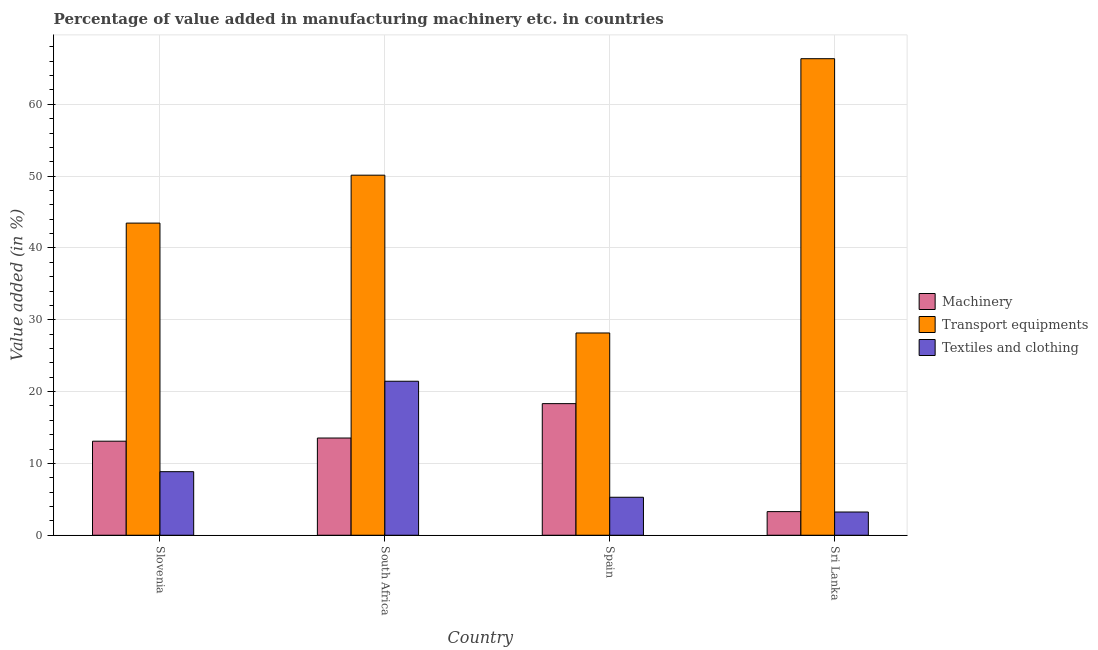How many different coloured bars are there?
Make the answer very short. 3. How many groups of bars are there?
Keep it short and to the point. 4. How many bars are there on the 3rd tick from the right?
Offer a very short reply. 3. In how many cases, is the number of bars for a given country not equal to the number of legend labels?
Keep it short and to the point. 0. What is the value added in manufacturing transport equipments in Spain?
Offer a very short reply. 28.16. Across all countries, what is the maximum value added in manufacturing textile and clothing?
Make the answer very short. 21.44. Across all countries, what is the minimum value added in manufacturing textile and clothing?
Provide a succinct answer. 3.23. In which country was the value added in manufacturing machinery maximum?
Keep it short and to the point. Spain. In which country was the value added in manufacturing machinery minimum?
Provide a short and direct response. Sri Lanka. What is the total value added in manufacturing textile and clothing in the graph?
Provide a succinct answer. 38.81. What is the difference between the value added in manufacturing transport equipments in Spain and that in Sri Lanka?
Provide a short and direct response. -38.19. What is the difference between the value added in manufacturing textile and clothing in Slovenia and the value added in manufacturing transport equipments in Sri Lanka?
Ensure brevity in your answer.  -57.5. What is the average value added in manufacturing textile and clothing per country?
Your answer should be very brief. 9.7. What is the difference between the value added in manufacturing machinery and value added in manufacturing textile and clothing in Spain?
Offer a terse response. 13.03. What is the ratio of the value added in manufacturing transport equipments in Spain to that in Sri Lanka?
Offer a very short reply. 0.42. What is the difference between the highest and the second highest value added in manufacturing textile and clothing?
Ensure brevity in your answer.  12.59. What is the difference between the highest and the lowest value added in manufacturing textile and clothing?
Give a very brief answer. 18.21. What does the 1st bar from the left in Slovenia represents?
Offer a very short reply. Machinery. What does the 3rd bar from the right in Spain represents?
Offer a terse response. Machinery. How many bars are there?
Provide a short and direct response. 12. How many countries are there in the graph?
Provide a short and direct response. 4. Does the graph contain grids?
Offer a terse response. Yes. Where does the legend appear in the graph?
Ensure brevity in your answer.  Center right. What is the title of the graph?
Your response must be concise. Percentage of value added in manufacturing machinery etc. in countries. What is the label or title of the Y-axis?
Provide a short and direct response. Value added (in %). What is the Value added (in %) of Machinery in Slovenia?
Your response must be concise. 13.09. What is the Value added (in %) of Transport equipments in Slovenia?
Offer a terse response. 43.46. What is the Value added (in %) of Textiles and clothing in Slovenia?
Ensure brevity in your answer.  8.85. What is the Value added (in %) in Machinery in South Africa?
Your answer should be compact. 13.54. What is the Value added (in %) in Transport equipments in South Africa?
Your response must be concise. 50.13. What is the Value added (in %) in Textiles and clothing in South Africa?
Ensure brevity in your answer.  21.44. What is the Value added (in %) of Machinery in Spain?
Your answer should be compact. 18.32. What is the Value added (in %) in Transport equipments in Spain?
Offer a very short reply. 28.16. What is the Value added (in %) in Textiles and clothing in Spain?
Your response must be concise. 5.29. What is the Value added (in %) of Machinery in Sri Lanka?
Offer a very short reply. 3.29. What is the Value added (in %) of Transport equipments in Sri Lanka?
Keep it short and to the point. 66.35. What is the Value added (in %) of Textiles and clothing in Sri Lanka?
Provide a short and direct response. 3.23. Across all countries, what is the maximum Value added (in %) in Machinery?
Keep it short and to the point. 18.32. Across all countries, what is the maximum Value added (in %) of Transport equipments?
Provide a succinct answer. 66.35. Across all countries, what is the maximum Value added (in %) in Textiles and clothing?
Your answer should be compact. 21.44. Across all countries, what is the minimum Value added (in %) of Machinery?
Ensure brevity in your answer.  3.29. Across all countries, what is the minimum Value added (in %) of Transport equipments?
Your answer should be very brief. 28.16. Across all countries, what is the minimum Value added (in %) in Textiles and clothing?
Make the answer very short. 3.23. What is the total Value added (in %) of Machinery in the graph?
Ensure brevity in your answer.  48.24. What is the total Value added (in %) of Transport equipments in the graph?
Your answer should be compact. 188.09. What is the total Value added (in %) of Textiles and clothing in the graph?
Give a very brief answer. 38.81. What is the difference between the Value added (in %) in Machinery in Slovenia and that in South Africa?
Give a very brief answer. -0.44. What is the difference between the Value added (in %) in Transport equipments in Slovenia and that in South Africa?
Offer a terse response. -6.67. What is the difference between the Value added (in %) of Textiles and clothing in Slovenia and that in South Africa?
Your answer should be very brief. -12.59. What is the difference between the Value added (in %) of Machinery in Slovenia and that in Spain?
Give a very brief answer. -5.23. What is the difference between the Value added (in %) in Transport equipments in Slovenia and that in Spain?
Provide a short and direct response. 15.3. What is the difference between the Value added (in %) of Textiles and clothing in Slovenia and that in Spain?
Your answer should be compact. 3.56. What is the difference between the Value added (in %) in Machinery in Slovenia and that in Sri Lanka?
Keep it short and to the point. 9.8. What is the difference between the Value added (in %) of Transport equipments in Slovenia and that in Sri Lanka?
Your response must be concise. -22.89. What is the difference between the Value added (in %) in Textiles and clothing in Slovenia and that in Sri Lanka?
Your answer should be very brief. 5.61. What is the difference between the Value added (in %) in Machinery in South Africa and that in Spain?
Give a very brief answer. -4.79. What is the difference between the Value added (in %) in Transport equipments in South Africa and that in Spain?
Offer a terse response. 21.97. What is the difference between the Value added (in %) of Textiles and clothing in South Africa and that in Spain?
Offer a very short reply. 16.15. What is the difference between the Value added (in %) in Machinery in South Africa and that in Sri Lanka?
Make the answer very short. 10.25. What is the difference between the Value added (in %) of Transport equipments in South Africa and that in Sri Lanka?
Your answer should be compact. -16.22. What is the difference between the Value added (in %) in Textiles and clothing in South Africa and that in Sri Lanka?
Offer a terse response. 18.21. What is the difference between the Value added (in %) in Machinery in Spain and that in Sri Lanka?
Make the answer very short. 15.03. What is the difference between the Value added (in %) in Transport equipments in Spain and that in Sri Lanka?
Make the answer very short. -38.19. What is the difference between the Value added (in %) of Textiles and clothing in Spain and that in Sri Lanka?
Your answer should be compact. 2.05. What is the difference between the Value added (in %) of Machinery in Slovenia and the Value added (in %) of Transport equipments in South Africa?
Your response must be concise. -37.04. What is the difference between the Value added (in %) of Machinery in Slovenia and the Value added (in %) of Textiles and clothing in South Africa?
Offer a very short reply. -8.35. What is the difference between the Value added (in %) in Transport equipments in Slovenia and the Value added (in %) in Textiles and clothing in South Africa?
Provide a succinct answer. 22.02. What is the difference between the Value added (in %) in Machinery in Slovenia and the Value added (in %) in Transport equipments in Spain?
Your answer should be compact. -15.07. What is the difference between the Value added (in %) in Machinery in Slovenia and the Value added (in %) in Textiles and clothing in Spain?
Make the answer very short. 7.8. What is the difference between the Value added (in %) of Transport equipments in Slovenia and the Value added (in %) of Textiles and clothing in Spain?
Give a very brief answer. 38.17. What is the difference between the Value added (in %) in Machinery in Slovenia and the Value added (in %) in Transport equipments in Sri Lanka?
Provide a short and direct response. -53.25. What is the difference between the Value added (in %) in Machinery in Slovenia and the Value added (in %) in Textiles and clothing in Sri Lanka?
Give a very brief answer. 9.86. What is the difference between the Value added (in %) in Transport equipments in Slovenia and the Value added (in %) in Textiles and clothing in Sri Lanka?
Make the answer very short. 40.22. What is the difference between the Value added (in %) of Machinery in South Africa and the Value added (in %) of Transport equipments in Spain?
Your answer should be very brief. -14.63. What is the difference between the Value added (in %) of Machinery in South Africa and the Value added (in %) of Textiles and clothing in Spain?
Your response must be concise. 8.25. What is the difference between the Value added (in %) in Transport equipments in South Africa and the Value added (in %) in Textiles and clothing in Spain?
Keep it short and to the point. 44.84. What is the difference between the Value added (in %) of Machinery in South Africa and the Value added (in %) of Transport equipments in Sri Lanka?
Your answer should be compact. -52.81. What is the difference between the Value added (in %) of Machinery in South Africa and the Value added (in %) of Textiles and clothing in Sri Lanka?
Ensure brevity in your answer.  10.3. What is the difference between the Value added (in %) in Transport equipments in South Africa and the Value added (in %) in Textiles and clothing in Sri Lanka?
Your response must be concise. 46.9. What is the difference between the Value added (in %) in Machinery in Spain and the Value added (in %) in Transport equipments in Sri Lanka?
Your answer should be very brief. -48.02. What is the difference between the Value added (in %) of Machinery in Spain and the Value added (in %) of Textiles and clothing in Sri Lanka?
Make the answer very short. 15.09. What is the difference between the Value added (in %) of Transport equipments in Spain and the Value added (in %) of Textiles and clothing in Sri Lanka?
Your answer should be very brief. 24.93. What is the average Value added (in %) of Machinery per country?
Keep it short and to the point. 12.06. What is the average Value added (in %) of Transport equipments per country?
Offer a very short reply. 47.02. What is the average Value added (in %) in Textiles and clothing per country?
Your response must be concise. 9.7. What is the difference between the Value added (in %) of Machinery and Value added (in %) of Transport equipments in Slovenia?
Your response must be concise. -30.36. What is the difference between the Value added (in %) of Machinery and Value added (in %) of Textiles and clothing in Slovenia?
Provide a succinct answer. 4.24. What is the difference between the Value added (in %) of Transport equipments and Value added (in %) of Textiles and clothing in Slovenia?
Your answer should be very brief. 34.61. What is the difference between the Value added (in %) in Machinery and Value added (in %) in Transport equipments in South Africa?
Give a very brief answer. -36.6. What is the difference between the Value added (in %) of Machinery and Value added (in %) of Textiles and clothing in South Africa?
Provide a succinct answer. -7.91. What is the difference between the Value added (in %) in Transport equipments and Value added (in %) in Textiles and clothing in South Africa?
Offer a very short reply. 28.69. What is the difference between the Value added (in %) in Machinery and Value added (in %) in Transport equipments in Spain?
Offer a terse response. -9.84. What is the difference between the Value added (in %) of Machinery and Value added (in %) of Textiles and clothing in Spain?
Make the answer very short. 13.03. What is the difference between the Value added (in %) in Transport equipments and Value added (in %) in Textiles and clothing in Spain?
Your answer should be very brief. 22.87. What is the difference between the Value added (in %) in Machinery and Value added (in %) in Transport equipments in Sri Lanka?
Offer a very short reply. -63.06. What is the difference between the Value added (in %) of Machinery and Value added (in %) of Textiles and clothing in Sri Lanka?
Your answer should be very brief. 0.05. What is the difference between the Value added (in %) in Transport equipments and Value added (in %) in Textiles and clothing in Sri Lanka?
Provide a short and direct response. 63.11. What is the ratio of the Value added (in %) in Machinery in Slovenia to that in South Africa?
Offer a very short reply. 0.97. What is the ratio of the Value added (in %) in Transport equipments in Slovenia to that in South Africa?
Make the answer very short. 0.87. What is the ratio of the Value added (in %) in Textiles and clothing in Slovenia to that in South Africa?
Offer a very short reply. 0.41. What is the ratio of the Value added (in %) of Machinery in Slovenia to that in Spain?
Ensure brevity in your answer.  0.71. What is the ratio of the Value added (in %) of Transport equipments in Slovenia to that in Spain?
Ensure brevity in your answer.  1.54. What is the ratio of the Value added (in %) in Textiles and clothing in Slovenia to that in Spain?
Make the answer very short. 1.67. What is the ratio of the Value added (in %) of Machinery in Slovenia to that in Sri Lanka?
Your answer should be very brief. 3.98. What is the ratio of the Value added (in %) in Transport equipments in Slovenia to that in Sri Lanka?
Make the answer very short. 0.66. What is the ratio of the Value added (in %) of Textiles and clothing in Slovenia to that in Sri Lanka?
Give a very brief answer. 2.74. What is the ratio of the Value added (in %) of Machinery in South Africa to that in Spain?
Offer a very short reply. 0.74. What is the ratio of the Value added (in %) of Transport equipments in South Africa to that in Spain?
Your answer should be compact. 1.78. What is the ratio of the Value added (in %) in Textiles and clothing in South Africa to that in Spain?
Give a very brief answer. 4.05. What is the ratio of the Value added (in %) in Machinery in South Africa to that in Sri Lanka?
Your answer should be compact. 4.12. What is the ratio of the Value added (in %) of Transport equipments in South Africa to that in Sri Lanka?
Make the answer very short. 0.76. What is the ratio of the Value added (in %) of Textiles and clothing in South Africa to that in Sri Lanka?
Keep it short and to the point. 6.63. What is the ratio of the Value added (in %) in Machinery in Spain to that in Sri Lanka?
Offer a terse response. 5.57. What is the ratio of the Value added (in %) of Transport equipments in Spain to that in Sri Lanka?
Keep it short and to the point. 0.42. What is the ratio of the Value added (in %) in Textiles and clothing in Spain to that in Sri Lanka?
Provide a short and direct response. 1.63. What is the difference between the highest and the second highest Value added (in %) in Machinery?
Give a very brief answer. 4.79. What is the difference between the highest and the second highest Value added (in %) in Transport equipments?
Provide a succinct answer. 16.22. What is the difference between the highest and the second highest Value added (in %) in Textiles and clothing?
Your answer should be compact. 12.59. What is the difference between the highest and the lowest Value added (in %) in Machinery?
Keep it short and to the point. 15.03. What is the difference between the highest and the lowest Value added (in %) of Transport equipments?
Your answer should be compact. 38.19. What is the difference between the highest and the lowest Value added (in %) in Textiles and clothing?
Provide a succinct answer. 18.21. 